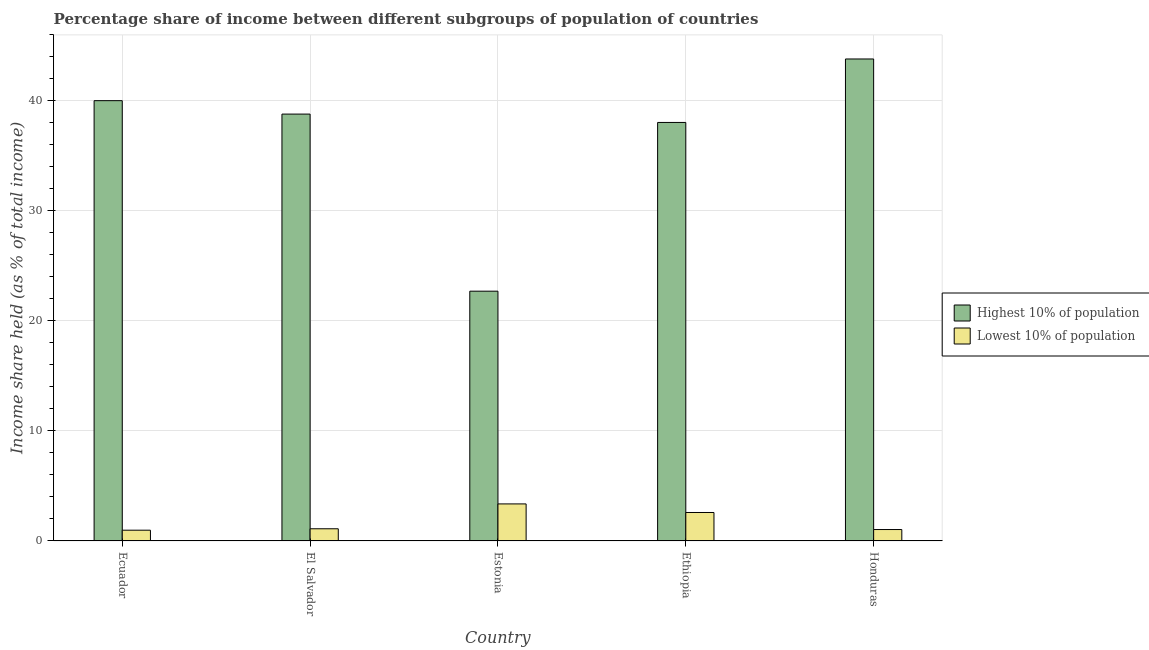How many different coloured bars are there?
Provide a short and direct response. 2. Are the number of bars per tick equal to the number of legend labels?
Give a very brief answer. Yes. Are the number of bars on each tick of the X-axis equal?
Your answer should be very brief. Yes. How many bars are there on the 2nd tick from the right?
Give a very brief answer. 2. What is the label of the 3rd group of bars from the left?
Provide a short and direct response. Estonia. What is the income share held by lowest 10% of the population in El Salvador?
Your response must be concise. 1.11. Across all countries, what is the maximum income share held by lowest 10% of the population?
Your answer should be very brief. 3.37. Across all countries, what is the minimum income share held by lowest 10% of the population?
Give a very brief answer. 0.98. In which country was the income share held by highest 10% of the population maximum?
Ensure brevity in your answer.  Honduras. In which country was the income share held by lowest 10% of the population minimum?
Provide a succinct answer. Ecuador. What is the total income share held by lowest 10% of the population in the graph?
Make the answer very short. 9.09. What is the difference between the income share held by highest 10% of the population in Estonia and that in Ethiopia?
Keep it short and to the point. -15.34. What is the difference between the income share held by lowest 10% of the population in Ecuador and the income share held by highest 10% of the population in Honduras?
Provide a succinct answer. -42.84. What is the average income share held by lowest 10% of the population per country?
Your answer should be very brief. 1.82. What is the difference between the income share held by lowest 10% of the population and income share held by highest 10% of the population in Estonia?
Keep it short and to the point. -19.34. What is the ratio of the income share held by highest 10% of the population in Estonia to that in Ethiopia?
Provide a succinct answer. 0.6. Is the difference between the income share held by highest 10% of the population in Estonia and Ethiopia greater than the difference between the income share held by lowest 10% of the population in Estonia and Ethiopia?
Offer a terse response. No. What is the difference between the highest and the second highest income share held by lowest 10% of the population?
Provide a short and direct response. 0.78. What is the difference between the highest and the lowest income share held by lowest 10% of the population?
Keep it short and to the point. 2.39. In how many countries, is the income share held by lowest 10% of the population greater than the average income share held by lowest 10% of the population taken over all countries?
Provide a succinct answer. 2. Is the sum of the income share held by lowest 10% of the population in Ecuador and Estonia greater than the maximum income share held by highest 10% of the population across all countries?
Provide a succinct answer. No. What does the 1st bar from the left in Ethiopia represents?
Your answer should be compact. Highest 10% of population. What does the 1st bar from the right in Ecuador represents?
Offer a terse response. Lowest 10% of population. How many bars are there?
Offer a terse response. 10. Are the values on the major ticks of Y-axis written in scientific E-notation?
Keep it short and to the point. No. Does the graph contain any zero values?
Offer a terse response. No. Does the graph contain grids?
Make the answer very short. Yes. Where does the legend appear in the graph?
Ensure brevity in your answer.  Center right. How many legend labels are there?
Keep it short and to the point. 2. What is the title of the graph?
Your answer should be very brief. Percentage share of income between different subgroups of population of countries. Does "National Visitors" appear as one of the legend labels in the graph?
Your answer should be compact. No. What is the label or title of the X-axis?
Your response must be concise. Country. What is the label or title of the Y-axis?
Offer a terse response. Income share held (as % of total income). What is the Income share held (as % of total income) of Highest 10% of population in Ecuador?
Your response must be concise. 40.03. What is the Income share held (as % of total income) in Lowest 10% of population in Ecuador?
Your response must be concise. 0.98. What is the Income share held (as % of total income) of Highest 10% of population in El Salvador?
Provide a short and direct response. 38.81. What is the Income share held (as % of total income) in Lowest 10% of population in El Salvador?
Provide a short and direct response. 1.11. What is the Income share held (as % of total income) of Highest 10% of population in Estonia?
Ensure brevity in your answer.  22.71. What is the Income share held (as % of total income) of Lowest 10% of population in Estonia?
Your response must be concise. 3.37. What is the Income share held (as % of total income) in Highest 10% of population in Ethiopia?
Provide a short and direct response. 38.05. What is the Income share held (as % of total income) in Lowest 10% of population in Ethiopia?
Provide a succinct answer. 2.59. What is the Income share held (as % of total income) of Highest 10% of population in Honduras?
Keep it short and to the point. 43.82. What is the Income share held (as % of total income) in Lowest 10% of population in Honduras?
Your response must be concise. 1.04. Across all countries, what is the maximum Income share held (as % of total income) in Highest 10% of population?
Provide a succinct answer. 43.82. Across all countries, what is the maximum Income share held (as % of total income) of Lowest 10% of population?
Your response must be concise. 3.37. Across all countries, what is the minimum Income share held (as % of total income) in Highest 10% of population?
Give a very brief answer. 22.71. What is the total Income share held (as % of total income) in Highest 10% of population in the graph?
Keep it short and to the point. 183.42. What is the total Income share held (as % of total income) of Lowest 10% of population in the graph?
Make the answer very short. 9.09. What is the difference between the Income share held (as % of total income) in Highest 10% of population in Ecuador and that in El Salvador?
Your answer should be compact. 1.22. What is the difference between the Income share held (as % of total income) of Lowest 10% of population in Ecuador and that in El Salvador?
Your answer should be compact. -0.13. What is the difference between the Income share held (as % of total income) in Highest 10% of population in Ecuador and that in Estonia?
Ensure brevity in your answer.  17.32. What is the difference between the Income share held (as % of total income) of Lowest 10% of population in Ecuador and that in Estonia?
Provide a succinct answer. -2.39. What is the difference between the Income share held (as % of total income) in Highest 10% of population in Ecuador and that in Ethiopia?
Provide a short and direct response. 1.98. What is the difference between the Income share held (as % of total income) in Lowest 10% of population in Ecuador and that in Ethiopia?
Keep it short and to the point. -1.61. What is the difference between the Income share held (as % of total income) of Highest 10% of population in Ecuador and that in Honduras?
Ensure brevity in your answer.  -3.79. What is the difference between the Income share held (as % of total income) of Lowest 10% of population in Ecuador and that in Honduras?
Keep it short and to the point. -0.06. What is the difference between the Income share held (as % of total income) in Highest 10% of population in El Salvador and that in Estonia?
Your answer should be very brief. 16.1. What is the difference between the Income share held (as % of total income) in Lowest 10% of population in El Salvador and that in Estonia?
Provide a short and direct response. -2.26. What is the difference between the Income share held (as % of total income) of Highest 10% of population in El Salvador and that in Ethiopia?
Offer a terse response. 0.76. What is the difference between the Income share held (as % of total income) of Lowest 10% of population in El Salvador and that in Ethiopia?
Offer a very short reply. -1.48. What is the difference between the Income share held (as % of total income) in Highest 10% of population in El Salvador and that in Honduras?
Your response must be concise. -5.01. What is the difference between the Income share held (as % of total income) in Lowest 10% of population in El Salvador and that in Honduras?
Provide a succinct answer. 0.07. What is the difference between the Income share held (as % of total income) of Highest 10% of population in Estonia and that in Ethiopia?
Your response must be concise. -15.34. What is the difference between the Income share held (as % of total income) of Lowest 10% of population in Estonia and that in Ethiopia?
Offer a very short reply. 0.78. What is the difference between the Income share held (as % of total income) of Highest 10% of population in Estonia and that in Honduras?
Give a very brief answer. -21.11. What is the difference between the Income share held (as % of total income) in Lowest 10% of population in Estonia and that in Honduras?
Provide a short and direct response. 2.33. What is the difference between the Income share held (as % of total income) of Highest 10% of population in Ethiopia and that in Honduras?
Keep it short and to the point. -5.77. What is the difference between the Income share held (as % of total income) in Lowest 10% of population in Ethiopia and that in Honduras?
Ensure brevity in your answer.  1.55. What is the difference between the Income share held (as % of total income) in Highest 10% of population in Ecuador and the Income share held (as % of total income) in Lowest 10% of population in El Salvador?
Provide a short and direct response. 38.92. What is the difference between the Income share held (as % of total income) in Highest 10% of population in Ecuador and the Income share held (as % of total income) in Lowest 10% of population in Estonia?
Your answer should be compact. 36.66. What is the difference between the Income share held (as % of total income) in Highest 10% of population in Ecuador and the Income share held (as % of total income) in Lowest 10% of population in Ethiopia?
Give a very brief answer. 37.44. What is the difference between the Income share held (as % of total income) of Highest 10% of population in Ecuador and the Income share held (as % of total income) of Lowest 10% of population in Honduras?
Provide a succinct answer. 38.99. What is the difference between the Income share held (as % of total income) in Highest 10% of population in El Salvador and the Income share held (as % of total income) in Lowest 10% of population in Estonia?
Your answer should be very brief. 35.44. What is the difference between the Income share held (as % of total income) of Highest 10% of population in El Salvador and the Income share held (as % of total income) of Lowest 10% of population in Ethiopia?
Offer a terse response. 36.22. What is the difference between the Income share held (as % of total income) in Highest 10% of population in El Salvador and the Income share held (as % of total income) in Lowest 10% of population in Honduras?
Your answer should be compact. 37.77. What is the difference between the Income share held (as % of total income) of Highest 10% of population in Estonia and the Income share held (as % of total income) of Lowest 10% of population in Ethiopia?
Provide a succinct answer. 20.12. What is the difference between the Income share held (as % of total income) of Highest 10% of population in Estonia and the Income share held (as % of total income) of Lowest 10% of population in Honduras?
Make the answer very short. 21.67. What is the difference between the Income share held (as % of total income) of Highest 10% of population in Ethiopia and the Income share held (as % of total income) of Lowest 10% of population in Honduras?
Ensure brevity in your answer.  37.01. What is the average Income share held (as % of total income) of Highest 10% of population per country?
Provide a succinct answer. 36.68. What is the average Income share held (as % of total income) in Lowest 10% of population per country?
Keep it short and to the point. 1.82. What is the difference between the Income share held (as % of total income) of Highest 10% of population and Income share held (as % of total income) of Lowest 10% of population in Ecuador?
Your answer should be compact. 39.05. What is the difference between the Income share held (as % of total income) in Highest 10% of population and Income share held (as % of total income) in Lowest 10% of population in El Salvador?
Your answer should be compact. 37.7. What is the difference between the Income share held (as % of total income) in Highest 10% of population and Income share held (as % of total income) in Lowest 10% of population in Estonia?
Your answer should be compact. 19.34. What is the difference between the Income share held (as % of total income) in Highest 10% of population and Income share held (as % of total income) in Lowest 10% of population in Ethiopia?
Provide a succinct answer. 35.46. What is the difference between the Income share held (as % of total income) in Highest 10% of population and Income share held (as % of total income) in Lowest 10% of population in Honduras?
Your answer should be very brief. 42.78. What is the ratio of the Income share held (as % of total income) of Highest 10% of population in Ecuador to that in El Salvador?
Provide a short and direct response. 1.03. What is the ratio of the Income share held (as % of total income) of Lowest 10% of population in Ecuador to that in El Salvador?
Provide a succinct answer. 0.88. What is the ratio of the Income share held (as % of total income) in Highest 10% of population in Ecuador to that in Estonia?
Provide a short and direct response. 1.76. What is the ratio of the Income share held (as % of total income) of Lowest 10% of population in Ecuador to that in Estonia?
Ensure brevity in your answer.  0.29. What is the ratio of the Income share held (as % of total income) of Highest 10% of population in Ecuador to that in Ethiopia?
Offer a very short reply. 1.05. What is the ratio of the Income share held (as % of total income) in Lowest 10% of population in Ecuador to that in Ethiopia?
Provide a succinct answer. 0.38. What is the ratio of the Income share held (as % of total income) in Highest 10% of population in Ecuador to that in Honduras?
Ensure brevity in your answer.  0.91. What is the ratio of the Income share held (as % of total income) of Lowest 10% of population in Ecuador to that in Honduras?
Your answer should be very brief. 0.94. What is the ratio of the Income share held (as % of total income) of Highest 10% of population in El Salvador to that in Estonia?
Give a very brief answer. 1.71. What is the ratio of the Income share held (as % of total income) in Lowest 10% of population in El Salvador to that in Estonia?
Make the answer very short. 0.33. What is the ratio of the Income share held (as % of total income) of Lowest 10% of population in El Salvador to that in Ethiopia?
Ensure brevity in your answer.  0.43. What is the ratio of the Income share held (as % of total income) in Highest 10% of population in El Salvador to that in Honduras?
Your answer should be very brief. 0.89. What is the ratio of the Income share held (as % of total income) in Lowest 10% of population in El Salvador to that in Honduras?
Provide a short and direct response. 1.07. What is the ratio of the Income share held (as % of total income) in Highest 10% of population in Estonia to that in Ethiopia?
Make the answer very short. 0.6. What is the ratio of the Income share held (as % of total income) of Lowest 10% of population in Estonia to that in Ethiopia?
Keep it short and to the point. 1.3. What is the ratio of the Income share held (as % of total income) of Highest 10% of population in Estonia to that in Honduras?
Keep it short and to the point. 0.52. What is the ratio of the Income share held (as % of total income) of Lowest 10% of population in Estonia to that in Honduras?
Provide a short and direct response. 3.24. What is the ratio of the Income share held (as % of total income) of Highest 10% of population in Ethiopia to that in Honduras?
Your answer should be compact. 0.87. What is the ratio of the Income share held (as % of total income) in Lowest 10% of population in Ethiopia to that in Honduras?
Give a very brief answer. 2.49. What is the difference between the highest and the second highest Income share held (as % of total income) in Highest 10% of population?
Offer a very short reply. 3.79. What is the difference between the highest and the second highest Income share held (as % of total income) of Lowest 10% of population?
Give a very brief answer. 0.78. What is the difference between the highest and the lowest Income share held (as % of total income) in Highest 10% of population?
Provide a short and direct response. 21.11. What is the difference between the highest and the lowest Income share held (as % of total income) in Lowest 10% of population?
Offer a terse response. 2.39. 